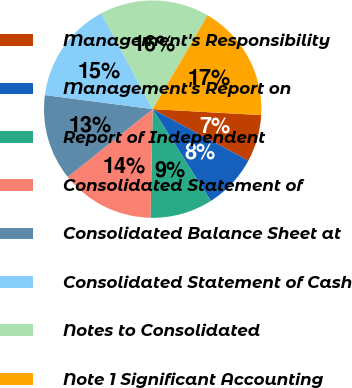<chart> <loc_0><loc_0><loc_500><loc_500><pie_chart><fcel>Management's Responsibility<fcel>Management's Report on<fcel>Report of Independent<fcel>Consolidated Statement of<fcel>Consolidated Balance Sheet at<fcel>Consolidated Statement of Cash<fcel>Notes to Consolidated<fcel>Note 1 Significant Accounting<nl><fcel>6.99%<fcel>8.15%<fcel>9.31%<fcel>13.95%<fcel>12.79%<fcel>15.11%<fcel>16.27%<fcel>17.43%<nl></chart> 